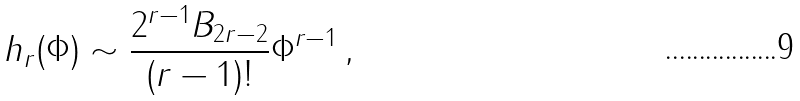<formula> <loc_0><loc_0><loc_500><loc_500>h _ { r } ( \Phi ) \sim \frac { 2 ^ { r - 1 } B _ { 2 r - 2 } } { ( r - 1 ) ! } \Phi ^ { r - 1 } \, ,</formula> 